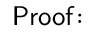<formula> <loc_0><loc_0><loc_500><loc_500>P r o o f \, \colon</formula> 